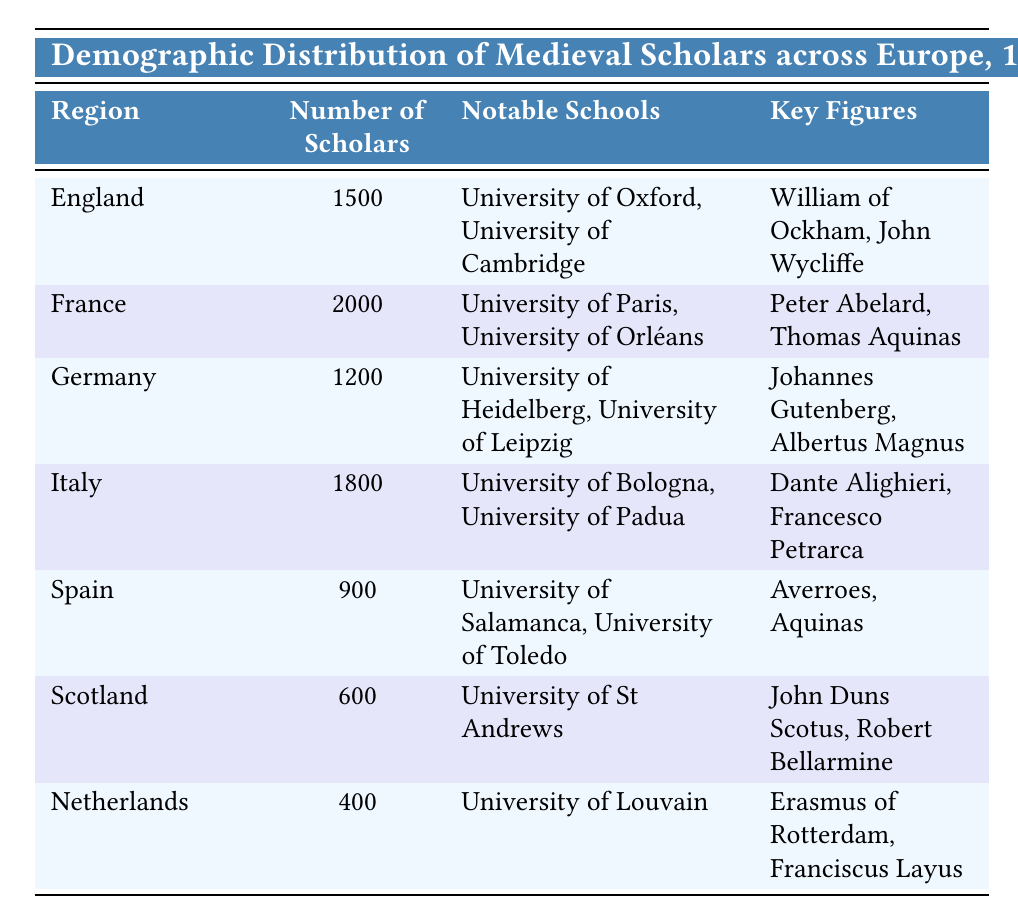What is the region with the highest number of scholars? The table lists the number of scholars for each region. France has the highest number with 2000 scholars, which is greater than that of any other region.
Answer: France How many scholars were there in Germany? The table directly states that Germany had 1200 scholars.
Answer: 1200 Which two key figures are associated with the University of Bologna? The table includes the key figures associated with notable schools. For the University of Bologna, the key figures are Dante Alighieri and Francesco Petrarca.
Answer: Dante Alighieri, Francesco Petrarca What is the total number of scholars across England, Italy, and Spain? The number of scholars for England (1500), Italy (1800), and Spain (900) are summed: 1500 + 1800 + 900 = 4200.
Answer: 4200 Is there a notable school listed for the Netherlands? The table indicates that the Netherlands has the University of Louvain as its notable school. Therefore, the answer is yes.
Answer: Yes Which region has the least number of scholars and how many are there? Looking at the numbers, the Netherlands has the least number of scholars with 400. This is confirmed by comparing the values listed in the table for each region.
Answer: Netherlands, 400 If we consider regions with more than 1000 scholars, how many notable schools are listed? The regions with more than 1000 scholars are France (2 schools), England (2 schools), Germany (2 schools), and Italy (2 schools). In total, that gives us 2 + 2 + 2 + 2 = 8 notable schools.
Answer: 8 Which region's notable schools include University of Salamanca? The table shows that the notable schools for Spain are the University of Salamanca and the University of Toledo. Therefore, Spain is associated with the University of Salamanca.
Answer: Spain What is the average number of scholars per region across the listed countries? There are seven regions, with a total number of scholars being (1500 + 2000 + 1200 + 1800 + 900 + 600 + 400) = 7500. To find the average, we divide 7500 by 7, yielding approximately 1071.43.
Answer: 1071.43 